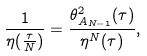<formula> <loc_0><loc_0><loc_500><loc_500>\frac { 1 } { \eta ( \frac { \tau } { N } ) } = \frac { \theta _ { A _ { N - 1 } } ^ { 2 } ( \tau ) } { \eta ^ { N } ( \tau ) } ,</formula> 